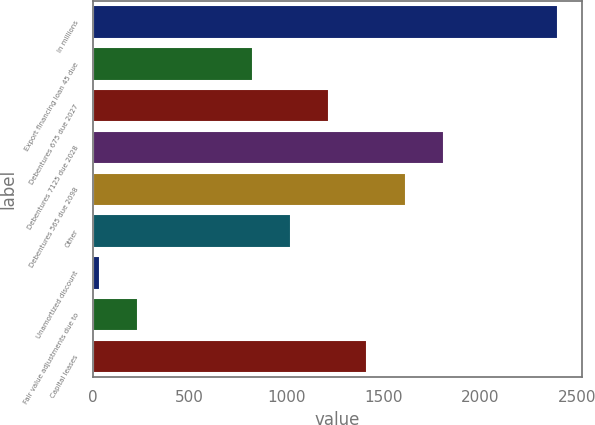<chart> <loc_0><loc_0><loc_500><loc_500><bar_chart><fcel>In millions<fcel>Export financing loan 45 due<fcel>Debentures 675 due 2027<fcel>Debentures 7125 due 2028<fcel>Debentures 565 due 2098<fcel>Other<fcel>Unamortized discount<fcel>Fair value adjustments due to<fcel>Capital leases<nl><fcel>2404.8<fcel>825.6<fcel>1220.4<fcel>1812.6<fcel>1615.2<fcel>1023<fcel>36<fcel>233.4<fcel>1417.8<nl></chart> 